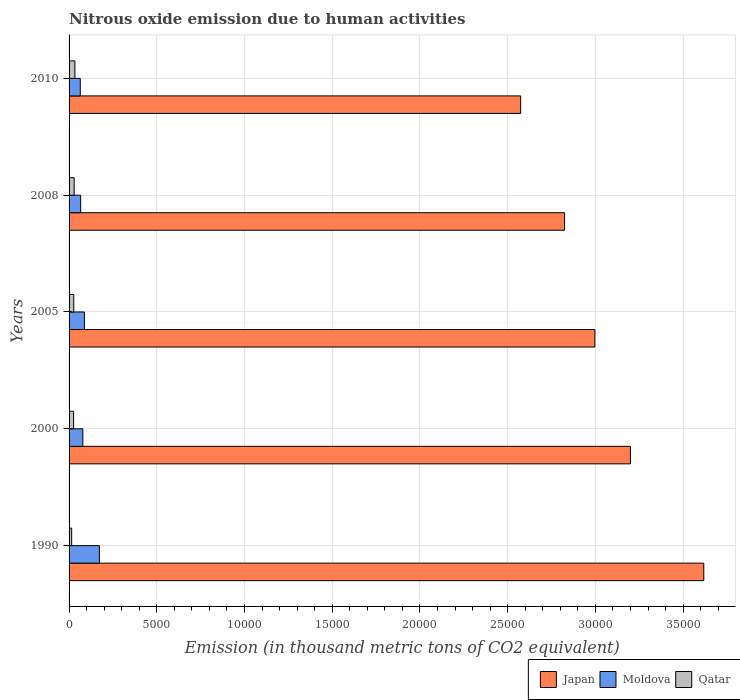How many different coloured bars are there?
Provide a short and direct response. 3. Are the number of bars per tick equal to the number of legend labels?
Ensure brevity in your answer.  Yes. How many bars are there on the 2nd tick from the top?
Your response must be concise. 3. How many bars are there on the 1st tick from the bottom?
Your answer should be very brief. 3. What is the amount of nitrous oxide emitted in Japan in 2008?
Keep it short and to the point. 2.82e+04. Across all years, what is the maximum amount of nitrous oxide emitted in Qatar?
Keep it short and to the point. 332.4. Across all years, what is the minimum amount of nitrous oxide emitted in Moldova?
Offer a terse response. 637.9. What is the total amount of nitrous oxide emitted in Moldova in the graph?
Give a very brief answer. 4685.7. What is the difference between the amount of nitrous oxide emitted in Japan in 1990 and that in 2000?
Your answer should be compact. 4179.1. What is the difference between the amount of nitrous oxide emitted in Moldova in 2010 and the amount of nitrous oxide emitted in Qatar in 2008?
Your answer should be very brief. 347.8. What is the average amount of nitrous oxide emitted in Japan per year?
Your answer should be compact. 3.04e+04. In the year 2008, what is the difference between the amount of nitrous oxide emitted in Qatar and amount of nitrous oxide emitted in Japan?
Your answer should be very brief. -2.80e+04. In how many years, is the amount of nitrous oxide emitted in Japan greater than 3000 thousand metric tons?
Your answer should be very brief. 5. What is the ratio of the amount of nitrous oxide emitted in Japan in 2008 to that in 2010?
Your answer should be compact. 1.1. Is the difference between the amount of nitrous oxide emitted in Qatar in 2005 and 2008 greater than the difference between the amount of nitrous oxide emitted in Japan in 2005 and 2008?
Provide a short and direct response. No. What is the difference between the highest and the second highest amount of nitrous oxide emitted in Moldova?
Provide a succinct answer. 855.4. What is the difference between the highest and the lowest amount of nitrous oxide emitted in Japan?
Provide a short and direct response. 1.04e+04. Is the sum of the amount of nitrous oxide emitted in Qatar in 2005 and 2010 greater than the maximum amount of nitrous oxide emitted in Moldova across all years?
Your answer should be very brief. No. What does the 2nd bar from the top in 2005 represents?
Ensure brevity in your answer.  Moldova. What does the 1st bar from the bottom in 2005 represents?
Ensure brevity in your answer.  Japan. Are all the bars in the graph horizontal?
Your answer should be very brief. Yes. How many years are there in the graph?
Provide a short and direct response. 5. Are the values on the major ticks of X-axis written in scientific E-notation?
Your answer should be very brief. No. Does the graph contain any zero values?
Give a very brief answer. No. Does the graph contain grids?
Make the answer very short. Yes. Where does the legend appear in the graph?
Your answer should be compact. Bottom right. What is the title of the graph?
Your answer should be very brief. Nitrous oxide emission due to human activities. Does "United Kingdom" appear as one of the legend labels in the graph?
Offer a terse response. No. What is the label or title of the X-axis?
Give a very brief answer. Emission (in thousand metric tons of CO2 equivalent). What is the Emission (in thousand metric tons of CO2 equivalent) in Japan in 1990?
Make the answer very short. 3.62e+04. What is the Emission (in thousand metric tons of CO2 equivalent) of Moldova in 1990?
Give a very brief answer. 1728.3. What is the Emission (in thousand metric tons of CO2 equivalent) in Qatar in 1990?
Provide a short and direct response. 147.6. What is the Emission (in thousand metric tons of CO2 equivalent) in Japan in 2000?
Offer a very short reply. 3.20e+04. What is the Emission (in thousand metric tons of CO2 equivalent) of Moldova in 2000?
Give a very brief answer. 785. What is the Emission (in thousand metric tons of CO2 equivalent) in Qatar in 2000?
Provide a short and direct response. 258.6. What is the Emission (in thousand metric tons of CO2 equivalent) in Japan in 2005?
Keep it short and to the point. 3.00e+04. What is the Emission (in thousand metric tons of CO2 equivalent) of Moldova in 2005?
Your answer should be very brief. 872.9. What is the Emission (in thousand metric tons of CO2 equivalent) in Qatar in 2005?
Provide a succinct answer. 267.6. What is the Emission (in thousand metric tons of CO2 equivalent) in Japan in 2008?
Make the answer very short. 2.82e+04. What is the Emission (in thousand metric tons of CO2 equivalent) in Moldova in 2008?
Offer a very short reply. 661.6. What is the Emission (in thousand metric tons of CO2 equivalent) in Qatar in 2008?
Make the answer very short. 290.1. What is the Emission (in thousand metric tons of CO2 equivalent) in Japan in 2010?
Your answer should be very brief. 2.57e+04. What is the Emission (in thousand metric tons of CO2 equivalent) of Moldova in 2010?
Ensure brevity in your answer.  637.9. What is the Emission (in thousand metric tons of CO2 equivalent) of Qatar in 2010?
Your answer should be very brief. 332.4. Across all years, what is the maximum Emission (in thousand metric tons of CO2 equivalent) of Japan?
Keep it short and to the point. 3.62e+04. Across all years, what is the maximum Emission (in thousand metric tons of CO2 equivalent) in Moldova?
Give a very brief answer. 1728.3. Across all years, what is the maximum Emission (in thousand metric tons of CO2 equivalent) in Qatar?
Your response must be concise. 332.4. Across all years, what is the minimum Emission (in thousand metric tons of CO2 equivalent) of Japan?
Ensure brevity in your answer.  2.57e+04. Across all years, what is the minimum Emission (in thousand metric tons of CO2 equivalent) in Moldova?
Keep it short and to the point. 637.9. Across all years, what is the minimum Emission (in thousand metric tons of CO2 equivalent) in Qatar?
Make the answer very short. 147.6. What is the total Emission (in thousand metric tons of CO2 equivalent) in Japan in the graph?
Give a very brief answer. 1.52e+05. What is the total Emission (in thousand metric tons of CO2 equivalent) in Moldova in the graph?
Ensure brevity in your answer.  4685.7. What is the total Emission (in thousand metric tons of CO2 equivalent) of Qatar in the graph?
Make the answer very short. 1296.3. What is the difference between the Emission (in thousand metric tons of CO2 equivalent) in Japan in 1990 and that in 2000?
Offer a very short reply. 4179.1. What is the difference between the Emission (in thousand metric tons of CO2 equivalent) in Moldova in 1990 and that in 2000?
Provide a short and direct response. 943.3. What is the difference between the Emission (in thousand metric tons of CO2 equivalent) of Qatar in 1990 and that in 2000?
Your answer should be very brief. -111. What is the difference between the Emission (in thousand metric tons of CO2 equivalent) of Japan in 1990 and that in 2005?
Your answer should be compact. 6206.6. What is the difference between the Emission (in thousand metric tons of CO2 equivalent) in Moldova in 1990 and that in 2005?
Ensure brevity in your answer.  855.4. What is the difference between the Emission (in thousand metric tons of CO2 equivalent) of Qatar in 1990 and that in 2005?
Offer a very short reply. -120. What is the difference between the Emission (in thousand metric tons of CO2 equivalent) in Japan in 1990 and that in 2008?
Keep it short and to the point. 7932.2. What is the difference between the Emission (in thousand metric tons of CO2 equivalent) of Moldova in 1990 and that in 2008?
Give a very brief answer. 1066.7. What is the difference between the Emission (in thousand metric tons of CO2 equivalent) of Qatar in 1990 and that in 2008?
Give a very brief answer. -142.5. What is the difference between the Emission (in thousand metric tons of CO2 equivalent) of Japan in 1990 and that in 2010?
Ensure brevity in your answer.  1.04e+04. What is the difference between the Emission (in thousand metric tons of CO2 equivalent) of Moldova in 1990 and that in 2010?
Offer a very short reply. 1090.4. What is the difference between the Emission (in thousand metric tons of CO2 equivalent) of Qatar in 1990 and that in 2010?
Provide a short and direct response. -184.8. What is the difference between the Emission (in thousand metric tons of CO2 equivalent) of Japan in 2000 and that in 2005?
Give a very brief answer. 2027.5. What is the difference between the Emission (in thousand metric tons of CO2 equivalent) of Moldova in 2000 and that in 2005?
Give a very brief answer. -87.9. What is the difference between the Emission (in thousand metric tons of CO2 equivalent) of Japan in 2000 and that in 2008?
Offer a terse response. 3753.1. What is the difference between the Emission (in thousand metric tons of CO2 equivalent) in Moldova in 2000 and that in 2008?
Provide a short and direct response. 123.4. What is the difference between the Emission (in thousand metric tons of CO2 equivalent) of Qatar in 2000 and that in 2008?
Your answer should be very brief. -31.5. What is the difference between the Emission (in thousand metric tons of CO2 equivalent) of Japan in 2000 and that in 2010?
Keep it short and to the point. 6256.2. What is the difference between the Emission (in thousand metric tons of CO2 equivalent) of Moldova in 2000 and that in 2010?
Give a very brief answer. 147.1. What is the difference between the Emission (in thousand metric tons of CO2 equivalent) in Qatar in 2000 and that in 2010?
Your answer should be compact. -73.8. What is the difference between the Emission (in thousand metric tons of CO2 equivalent) of Japan in 2005 and that in 2008?
Give a very brief answer. 1725.6. What is the difference between the Emission (in thousand metric tons of CO2 equivalent) in Moldova in 2005 and that in 2008?
Provide a succinct answer. 211.3. What is the difference between the Emission (in thousand metric tons of CO2 equivalent) of Qatar in 2005 and that in 2008?
Your answer should be compact. -22.5. What is the difference between the Emission (in thousand metric tons of CO2 equivalent) in Japan in 2005 and that in 2010?
Your answer should be very brief. 4228.7. What is the difference between the Emission (in thousand metric tons of CO2 equivalent) in Moldova in 2005 and that in 2010?
Give a very brief answer. 235. What is the difference between the Emission (in thousand metric tons of CO2 equivalent) in Qatar in 2005 and that in 2010?
Your response must be concise. -64.8. What is the difference between the Emission (in thousand metric tons of CO2 equivalent) in Japan in 2008 and that in 2010?
Your answer should be very brief. 2503.1. What is the difference between the Emission (in thousand metric tons of CO2 equivalent) in Moldova in 2008 and that in 2010?
Give a very brief answer. 23.7. What is the difference between the Emission (in thousand metric tons of CO2 equivalent) in Qatar in 2008 and that in 2010?
Ensure brevity in your answer.  -42.3. What is the difference between the Emission (in thousand metric tons of CO2 equivalent) of Japan in 1990 and the Emission (in thousand metric tons of CO2 equivalent) of Moldova in 2000?
Provide a short and direct response. 3.54e+04. What is the difference between the Emission (in thousand metric tons of CO2 equivalent) in Japan in 1990 and the Emission (in thousand metric tons of CO2 equivalent) in Qatar in 2000?
Your response must be concise. 3.59e+04. What is the difference between the Emission (in thousand metric tons of CO2 equivalent) of Moldova in 1990 and the Emission (in thousand metric tons of CO2 equivalent) of Qatar in 2000?
Provide a succinct answer. 1469.7. What is the difference between the Emission (in thousand metric tons of CO2 equivalent) in Japan in 1990 and the Emission (in thousand metric tons of CO2 equivalent) in Moldova in 2005?
Provide a short and direct response. 3.53e+04. What is the difference between the Emission (in thousand metric tons of CO2 equivalent) of Japan in 1990 and the Emission (in thousand metric tons of CO2 equivalent) of Qatar in 2005?
Your response must be concise. 3.59e+04. What is the difference between the Emission (in thousand metric tons of CO2 equivalent) in Moldova in 1990 and the Emission (in thousand metric tons of CO2 equivalent) in Qatar in 2005?
Provide a succinct answer. 1460.7. What is the difference between the Emission (in thousand metric tons of CO2 equivalent) of Japan in 1990 and the Emission (in thousand metric tons of CO2 equivalent) of Moldova in 2008?
Your answer should be compact. 3.55e+04. What is the difference between the Emission (in thousand metric tons of CO2 equivalent) in Japan in 1990 and the Emission (in thousand metric tons of CO2 equivalent) in Qatar in 2008?
Give a very brief answer. 3.59e+04. What is the difference between the Emission (in thousand metric tons of CO2 equivalent) of Moldova in 1990 and the Emission (in thousand metric tons of CO2 equivalent) of Qatar in 2008?
Make the answer very short. 1438.2. What is the difference between the Emission (in thousand metric tons of CO2 equivalent) in Japan in 1990 and the Emission (in thousand metric tons of CO2 equivalent) in Moldova in 2010?
Keep it short and to the point. 3.55e+04. What is the difference between the Emission (in thousand metric tons of CO2 equivalent) in Japan in 1990 and the Emission (in thousand metric tons of CO2 equivalent) in Qatar in 2010?
Ensure brevity in your answer.  3.58e+04. What is the difference between the Emission (in thousand metric tons of CO2 equivalent) in Moldova in 1990 and the Emission (in thousand metric tons of CO2 equivalent) in Qatar in 2010?
Offer a very short reply. 1395.9. What is the difference between the Emission (in thousand metric tons of CO2 equivalent) in Japan in 2000 and the Emission (in thousand metric tons of CO2 equivalent) in Moldova in 2005?
Give a very brief answer. 3.11e+04. What is the difference between the Emission (in thousand metric tons of CO2 equivalent) of Japan in 2000 and the Emission (in thousand metric tons of CO2 equivalent) of Qatar in 2005?
Keep it short and to the point. 3.17e+04. What is the difference between the Emission (in thousand metric tons of CO2 equivalent) of Moldova in 2000 and the Emission (in thousand metric tons of CO2 equivalent) of Qatar in 2005?
Your response must be concise. 517.4. What is the difference between the Emission (in thousand metric tons of CO2 equivalent) of Japan in 2000 and the Emission (in thousand metric tons of CO2 equivalent) of Moldova in 2008?
Give a very brief answer. 3.13e+04. What is the difference between the Emission (in thousand metric tons of CO2 equivalent) of Japan in 2000 and the Emission (in thousand metric tons of CO2 equivalent) of Qatar in 2008?
Offer a terse response. 3.17e+04. What is the difference between the Emission (in thousand metric tons of CO2 equivalent) of Moldova in 2000 and the Emission (in thousand metric tons of CO2 equivalent) of Qatar in 2008?
Provide a short and direct response. 494.9. What is the difference between the Emission (in thousand metric tons of CO2 equivalent) in Japan in 2000 and the Emission (in thousand metric tons of CO2 equivalent) in Moldova in 2010?
Your answer should be compact. 3.14e+04. What is the difference between the Emission (in thousand metric tons of CO2 equivalent) of Japan in 2000 and the Emission (in thousand metric tons of CO2 equivalent) of Qatar in 2010?
Offer a very short reply. 3.17e+04. What is the difference between the Emission (in thousand metric tons of CO2 equivalent) in Moldova in 2000 and the Emission (in thousand metric tons of CO2 equivalent) in Qatar in 2010?
Ensure brevity in your answer.  452.6. What is the difference between the Emission (in thousand metric tons of CO2 equivalent) of Japan in 2005 and the Emission (in thousand metric tons of CO2 equivalent) of Moldova in 2008?
Offer a very short reply. 2.93e+04. What is the difference between the Emission (in thousand metric tons of CO2 equivalent) in Japan in 2005 and the Emission (in thousand metric tons of CO2 equivalent) in Qatar in 2008?
Offer a terse response. 2.97e+04. What is the difference between the Emission (in thousand metric tons of CO2 equivalent) of Moldova in 2005 and the Emission (in thousand metric tons of CO2 equivalent) of Qatar in 2008?
Ensure brevity in your answer.  582.8. What is the difference between the Emission (in thousand metric tons of CO2 equivalent) in Japan in 2005 and the Emission (in thousand metric tons of CO2 equivalent) in Moldova in 2010?
Your answer should be compact. 2.93e+04. What is the difference between the Emission (in thousand metric tons of CO2 equivalent) in Japan in 2005 and the Emission (in thousand metric tons of CO2 equivalent) in Qatar in 2010?
Provide a succinct answer. 2.96e+04. What is the difference between the Emission (in thousand metric tons of CO2 equivalent) in Moldova in 2005 and the Emission (in thousand metric tons of CO2 equivalent) in Qatar in 2010?
Your response must be concise. 540.5. What is the difference between the Emission (in thousand metric tons of CO2 equivalent) in Japan in 2008 and the Emission (in thousand metric tons of CO2 equivalent) in Moldova in 2010?
Your answer should be compact. 2.76e+04. What is the difference between the Emission (in thousand metric tons of CO2 equivalent) in Japan in 2008 and the Emission (in thousand metric tons of CO2 equivalent) in Qatar in 2010?
Offer a terse response. 2.79e+04. What is the difference between the Emission (in thousand metric tons of CO2 equivalent) in Moldova in 2008 and the Emission (in thousand metric tons of CO2 equivalent) in Qatar in 2010?
Provide a succinct answer. 329.2. What is the average Emission (in thousand metric tons of CO2 equivalent) of Japan per year?
Ensure brevity in your answer.  3.04e+04. What is the average Emission (in thousand metric tons of CO2 equivalent) in Moldova per year?
Your answer should be very brief. 937.14. What is the average Emission (in thousand metric tons of CO2 equivalent) of Qatar per year?
Keep it short and to the point. 259.26. In the year 1990, what is the difference between the Emission (in thousand metric tons of CO2 equivalent) in Japan and Emission (in thousand metric tons of CO2 equivalent) in Moldova?
Keep it short and to the point. 3.44e+04. In the year 1990, what is the difference between the Emission (in thousand metric tons of CO2 equivalent) of Japan and Emission (in thousand metric tons of CO2 equivalent) of Qatar?
Give a very brief answer. 3.60e+04. In the year 1990, what is the difference between the Emission (in thousand metric tons of CO2 equivalent) in Moldova and Emission (in thousand metric tons of CO2 equivalent) in Qatar?
Your response must be concise. 1580.7. In the year 2000, what is the difference between the Emission (in thousand metric tons of CO2 equivalent) of Japan and Emission (in thousand metric tons of CO2 equivalent) of Moldova?
Make the answer very short. 3.12e+04. In the year 2000, what is the difference between the Emission (in thousand metric tons of CO2 equivalent) in Japan and Emission (in thousand metric tons of CO2 equivalent) in Qatar?
Provide a succinct answer. 3.17e+04. In the year 2000, what is the difference between the Emission (in thousand metric tons of CO2 equivalent) in Moldova and Emission (in thousand metric tons of CO2 equivalent) in Qatar?
Offer a very short reply. 526.4. In the year 2005, what is the difference between the Emission (in thousand metric tons of CO2 equivalent) in Japan and Emission (in thousand metric tons of CO2 equivalent) in Moldova?
Provide a succinct answer. 2.91e+04. In the year 2005, what is the difference between the Emission (in thousand metric tons of CO2 equivalent) in Japan and Emission (in thousand metric tons of CO2 equivalent) in Qatar?
Offer a very short reply. 2.97e+04. In the year 2005, what is the difference between the Emission (in thousand metric tons of CO2 equivalent) in Moldova and Emission (in thousand metric tons of CO2 equivalent) in Qatar?
Offer a terse response. 605.3. In the year 2008, what is the difference between the Emission (in thousand metric tons of CO2 equivalent) of Japan and Emission (in thousand metric tons of CO2 equivalent) of Moldova?
Offer a very short reply. 2.76e+04. In the year 2008, what is the difference between the Emission (in thousand metric tons of CO2 equivalent) in Japan and Emission (in thousand metric tons of CO2 equivalent) in Qatar?
Provide a succinct answer. 2.80e+04. In the year 2008, what is the difference between the Emission (in thousand metric tons of CO2 equivalent) of Moldova and Emission (in thousand metric tons of CO2 equivalent) of Qatar?
Offer a terse response. 371.5. In the year 2010, what is the difference between the Emission (in thousand metric tons of CO2 equivalent) in Japan and Emission (in thousand metric tons of CO2 equivalent) in Moldova?
Ensure brevity in your answer.  2.51e+04. In the year 2010, what is the difference between the Emission (in thousand metric tons of CO2 equivalent) of Japan and Emission (in thousand metric tons of CO2 equivalent) of Qatar?
Keep it short and to the point. 2.54e+04. In the year 2010, what is the difference between the Emission (in thousand metric tons of CO2 equivalent) of Moldova and Emission (in thousand metric tons of CO2 equivalent) of Qatar?
Provide a short and direct response. 305.5. What is the ratio of the Emission (in thousand metric tons of CO2 equivalent) of Japan in 1990 to that in 2000?
Offer a terse response. 1.13. What is the ratio of the Emission (in thousand metric tons of CO2 equivalent) of Moldova in 1990 to that in 2000?
Your answer should be compact. 2.2. What is the ratio of the Emission (in thousand metric tons of CO2 equivalent) of Qatar in 1990 to that in 2000?
Ensure brevity in your answer.  0.57. What is the ratio of the Emission (in thousand metric tons of CO2 equivalent) in Japan in 1990 to that in 2005?
Give a very brief answer. 1.21. What is the ratio of the Emission (in thousand metric tons of CO2 equivalent) of Moldova in 1990 to that in 2005?
Give a very brief answer. 1.98. What is the ratio of the Emission (in thousand metric tons of CO2 equivalent) of Qatar in 1990 to that in 2005?
Ensure brevity in your answer.  0.55. What is the ratio of the Emission (in thousand metric tons of CO2 equivalent) in Japan in 1990 to that in 2008?
Offer a terse response. 1.28. What is the ratio of the Emission (in thousand metric tons of CO2 equivalent) of Moldova in 1990 to that in 2008?
Provide a short and direct response. 2.61. What is the ratio of the Emission (in thousand metric tons of CO2 equivalent) of Qatar in 1990 to that in 2008?
Give a very brief answer. 0.51. What is the ratio of the Emission (in thousand metric tons of CO2 equivalent) of Japan in 1990 to that in 2010?
Offer a very short reply. 1.41. What is the ratio of the Emission (in thousand metric tons of CO2 equivalent) in Moldova in 1990 to that in 2010?
Make the answer very short. 2.71. What is the ratio of the Emission (in thousand metric tons of CO2 equivalent) in Qatar in 1990 to that in 2010?
Offer a terse response. 0.44. What is the ratio of the Emission (in thousand metric tons of CO2 equivalent) in Japan in 2000 to that in 2005?
Provide a succinct answer. 1.07. What is the ratio of the Emission (in thousand metric tons of CO2 equivalent) in Moldova in 2000 to that in 2005?
Offer a very short reply. 0.9. What is the ratio of the Emission (in thousand metric tons of CO2 equivalent) of Qatar in 2000 to that in 2005?
Provide a short and direct response. 0.97. What is the ratio of the Emission (in thousand metric tons of CO2 equivalent) in Japan in 2000 to that in 2008?
Provide a short and direct response. 1.13. What is the ratio of the Emission (in thousand metric tons of CO2 equivalent) of Moldova in 2000 to that in 2008?
Keep it short and to the point. 1.19. What is the ratio of the Emission (in thousand metric tons of CO2 equivalent) in Qatar in 2000 to that in 2008?
Offer a very short reply. 0.89. What is the ratio of the Emission (in thousand metric tons of CO2 equivalent) of Japan in 2000 to that in 2010?
Make the answer very short. 1.24. What is the ratio of the Emission (in thousand metric tons of CO2 equivalent) of Moldova in 2000 to that in 2010?
Your response must be concise. 1.23. What is the ratio of the Emission (in thousand metric tons of CO2 equivalent) of Qatar in 2000 to that in 2010?
Offer a terse response. 0.78. What is the ratio of the Emission (in thousand metric tons of CO2 equivalent) in Japan in 2005 to that in 2008?
Provide a succinct answer. 1.06. What is the ratio of the Emission (in thousand metric tons of CO2 equivalent) of Moldova in 2005 to that in 2008?
Offer a terse response. 1.32. What is the ratio of the Emission (in thousand metric tons of CO2 equivalent) in Qatar in 2005 to that in 2008?
Make the answer very short. 0.92. What is the ratio of the Emission (in thousand metric tons of CO2 equivalent) in Japan in 2005 to that in 2010?
Make the answer very short. 1.16. What is the ratio of the Emission (in thousand metric tons of CO2 equivalent) in Moldova in 2005 to that in 2010?
Ensure brevity in your answer.  1.37. What is the ratio of the Emission (in thousand metric tons of CO2 equivalent) of Qatar in 2005 to that in 2010?
Your answer should be compact. 0.81. What is the ratio of the Emission (in thousand metric tons of CO2 equivalent) in Japan in 2008 to that in 2010?
Offer a very short reply. 1.1. What is the ratio of the Emission (in thousand metric tons of CO2 equivalent) in Moldova in 2008 to that in 2010?
Give a very brief answer. 1.04. What is the ratio of the Emission (in thousand metric tons of CO2 equivalent) of Qatar in 2008 to that in 2010?
Keep it short and to the point. 0.87. What is the difference between the highest and the second highest Emission (in thousand metric tons of CO2 equivalent) of Japan?
Keep it short and to the point. 4179.1. What is the difference between the highest and the second highest Emission (in thousand metric tons of CO2 equivalent) of Moldova?
Give a very brief answer. 855.4. What is the difference between the highest and the second highest Emission (in thousand metric tons of CO2 equivalent) of Qatar?
Give a very brief answer. 42.3. What is the difference between the highest and the lowest Emission (in thousand metric tons of CO2 equivalent) of Japan?
Your response must be concise. 1.04e+04. What is the difference between the highest and the lowest Emission (in thousand metric tons of CO2 equivalent) in Moldova?
Make the answer very short. 1090.4. What is the difference between the highest and the lowest Emission (in thousand metric tons of CO2 equivalent) of Qatar?
Your answer should be compact. 184.8. 